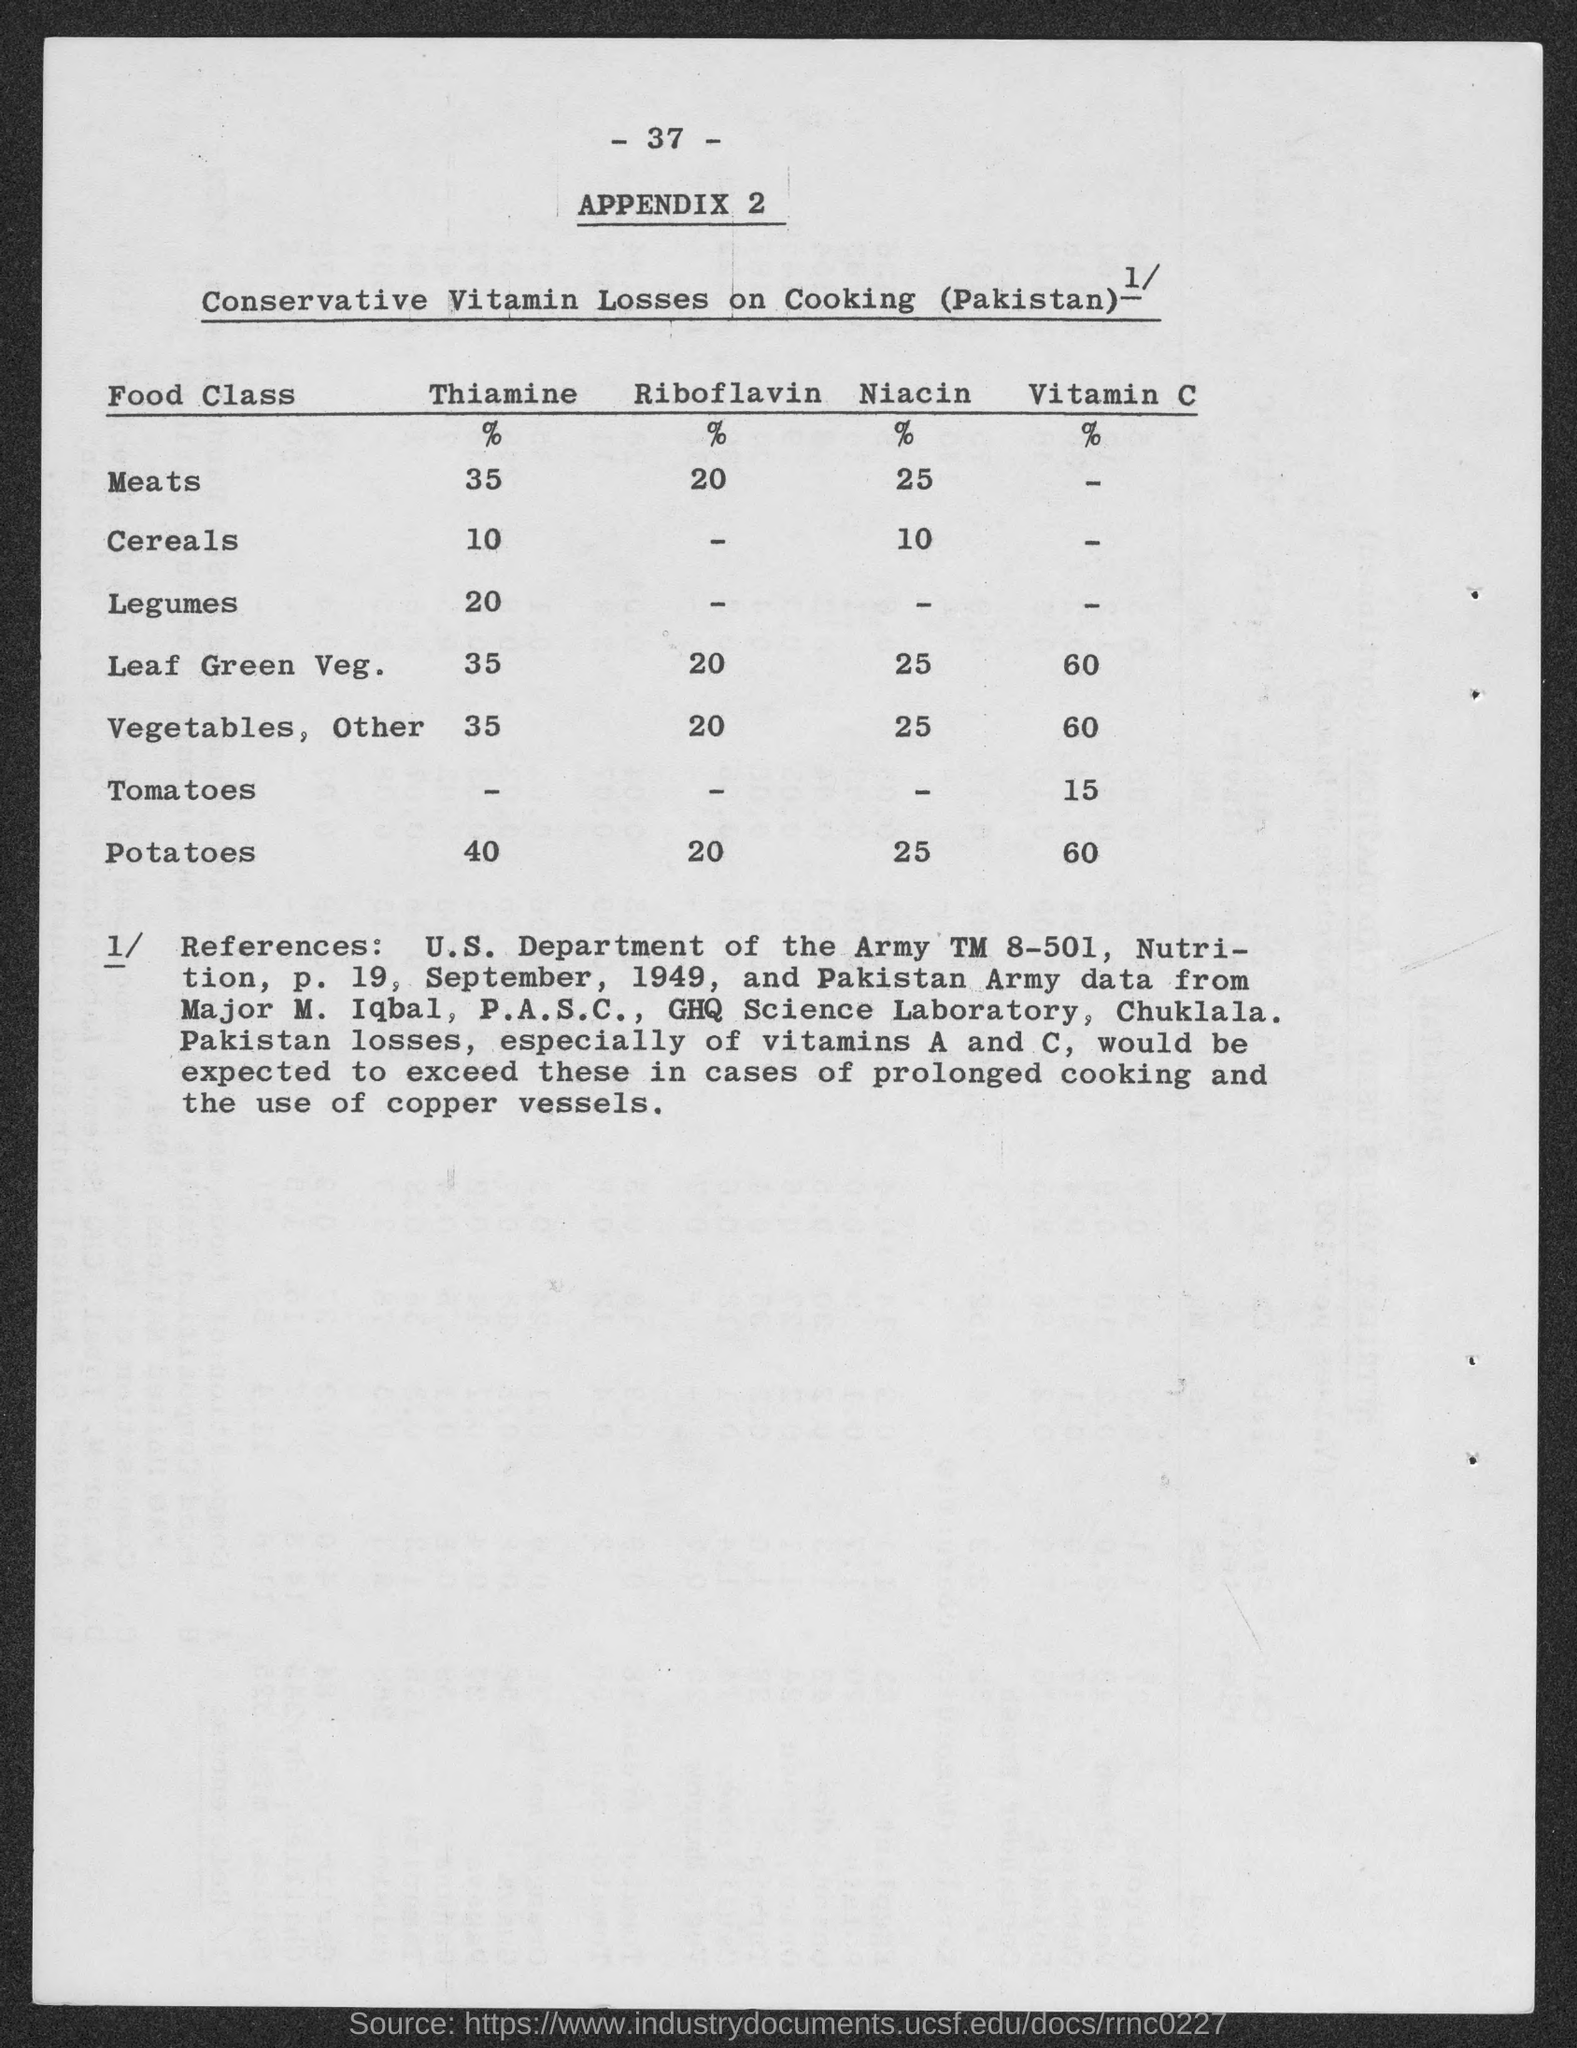Specify some key components in this picture. A total of 60% of the vitamin C content is available in leaf green vegetables. Approximately 20% of potatoes contain riboflavin. Thiamine content in meats is approximately 35%. According to a study, approximately 20% of thiamine is available in legumes. The availability of Vitamin C in tomatoes is approximately 15%. 